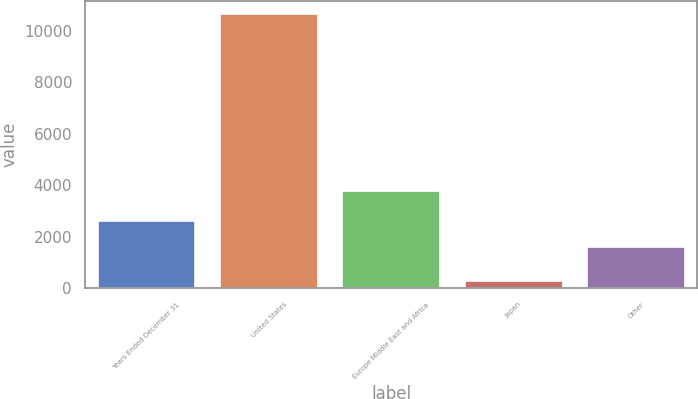Convert chart. <chart><loc_0><loc_0><loc_500><loc_500><bar_chart><fcel>Years Ended December 31<fcel>United States<fcel>Europe Middle East and Africa<fcel>Japan<fcel>Other<nl><fcel>2628.7<fcel>10646<fcel>3780<fcel>279<fcel>1592<nl></chart> 